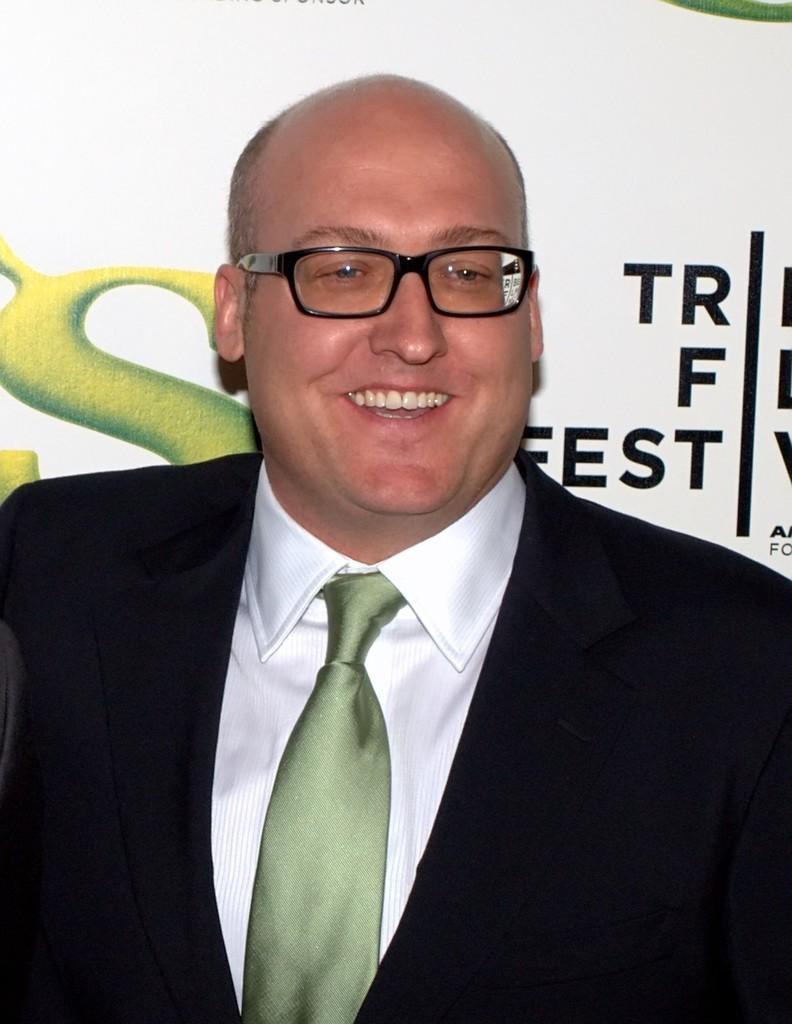Please provide a concise description of this image. In this picture we can see a man is smiling, he wore a suit and spectacles, in the background we can see some text. 